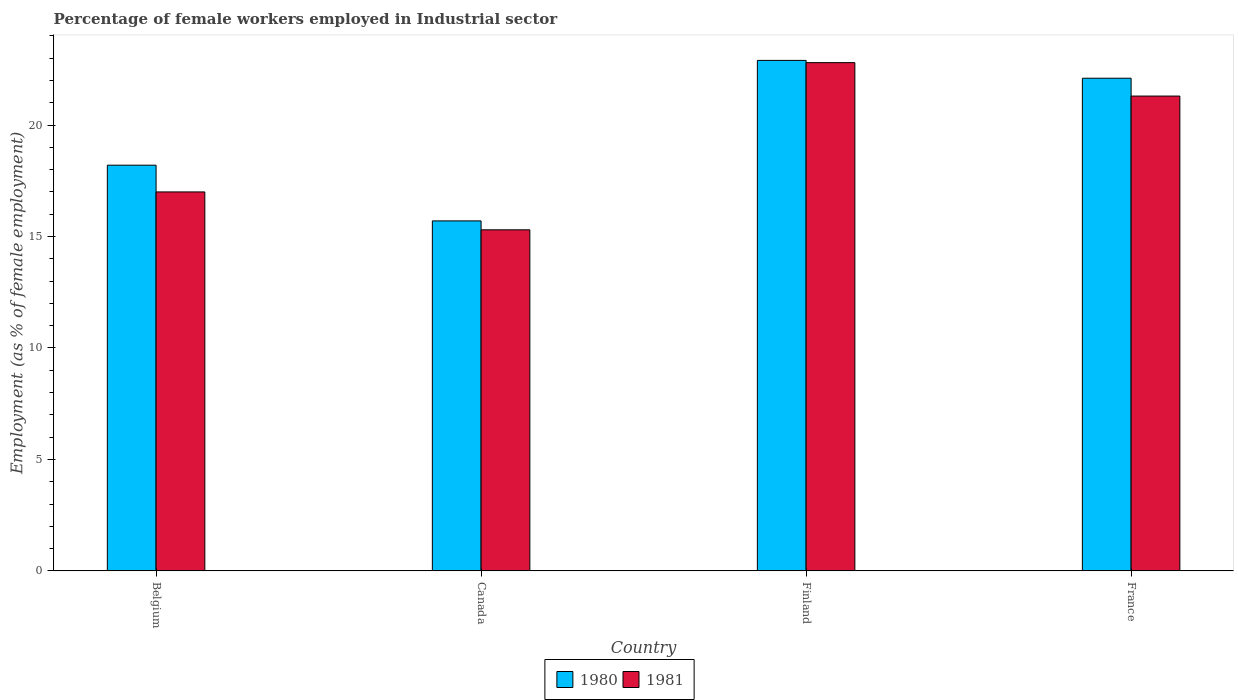Are the number of bars per tick equal to the number of legend labels?
Offer a terse response. Yes. What is the percentage of females employed in Industrial sector in 1981 in Finland?
Your answer should be compact. 22.8. Across all countries, what is the maximum percentage of females employed in Industrial sector in 1981?
Give a very brief answer. 22.8. Across all countries, what is the minimum percentage of females employed in Industrial sector in 1980?
Offer a terse response. 15.7. In which country was the percentage of females employed in Industrial sector in 1980 maximum?
Keep it short and to the point. Finland. In which country was the percentage of females employed in Industrial sector in 1980 minimum?
Give a very brief answer. Canada. What is the total percentage of females employed in Industrial sector in 1980 in the graph?
Provide a succinct answer. 78.9. What is the difference between the percentage of females employed in Industrial sector in 1980 in Belgium and that in Finland?
Offer a terse response. -4.7. What is the difference between the percentage of females employed in Industrial sector in 1981 in Finland and the percentage of females employed in Industrial sector in 1980 in Belgium?
Your response must be concise. 4.6. What is the average percentage of females employed in Industrial sector in 1981 per country?
Provide a short and direct response. 19.1. What is the difference between the percentage of females employed in Industrial sector of/in 1980 and percentage of females employed in Industrial sector of/in 1981 in France?
Your response must be concise. 0.8. In how many countries, is the percentage of females employed in Industrial sector in 1980 greater than 2 %?
Your answer should be very brief. 4. What is the ratio of the percentage of females employed in Industrial sector in 1980 in Belgium to that in France?
Provide a short and direct response. 0.82. Is the percentage of females employed in Industrial sector in 1981 in Belgium less than that in Finland?
Your response must be concise. Yes. Is the difference between the percentage of females employed in Industrial sector in 1980 in Canada and Finland greater than the difference between the percentage of females employed in Industrial sector in 1981 in Canada and Finland?
Your answer should be very brief. Yes. What is the difference between the highest and the second highest percentage of females employed in Industrial sector in 1981?
Keep it short and to the point. -4.3. What is the difference between the highest and the lowest percentage of females employed in Industrial sector in 1981?
Make the answer very short. 7.5. In how many countries, is the percentage of females employed in Industrial sector in 1980 greater than the average percentage of females employed in Industrial sector in 1980 taken over all countries?
Your answer should be very brief. 2. What does the 1st bar from the left in Canada represents?
Give a very brief answer. 1980. How many bars are there?
Your answer should be very brief. 8. Are all the bars in the graph horizontal?
Provide a short and direct response. No. What is the difference between two consecutive major ticks on the Y-axis?
Offer a terse response. 5. Where does the legend appear in the graph?
Provide a short and direct response. Bottom center. How are the legend labels stacked?
Your answer should be very brief. Horizontal. What is the title of the graph?
Ensure brevity in your answer.  Percentage of female workers employed in Industrial sector. Does "2006" appear as one of the legend labels in the graph?
Ensure brevity in your answer.  No. What is the label or title of the Y-axis?
Provide a short and direct response. Employment (as % of female employment). What is the Employment (as % of female employment) of 1980 in Belgium?
Your response must be concise. 18.2. What is the Employment (as % of female employment) in 1981 in Belgium?
Provide a short and direct response. 17. What is the Employment (as % of female employment) in 1980 in Canada?
Provide a succinct answer. 15.7. What is the Employment (as % of female employment) in 1981 in Canada?
Give a very brief answer. 15.3. What is the Employment (as % of female employment) of 1980 in Finland?
Keep it short and to the point. 22.9. What is the Employment (as % of female employment) in 1981 in Finland?
Provide a short and direct response. 22.8. What is the Employment (as % of female employment) in 1980 in France?
Keep it short and to the point. 22.1. What is the Employment (as % of female employment) of 1981 in France?
Make the answer very short. 21.3. Across all countries, what is the maximum Employment (as % of female employment) of 1980?
Offer a very short reply. 22.9. Across all countries, what is the maximum Employment (as % of female employment) in 1981?
Give a very brief answer. 22.8. Across all countries, what is the minimum Employment (as % of female employment) in 1980?
Your answer should be very brief. 15.7. Across all countries, what is the minimum Employment (as % of female employment) in 1981?
Your response must be concise. 15.3. What is the total Employment (as % of female employment) of 1980 in the graph?
Offer a terse response. 78.9. What is the total Employment (as % of female employment) of 1981 in the graph?
Keep it short and to the point. 76.4. What is the difference between the Employment (as % of female employment) of 1980 in Belgium and that in Canada?
Keep it short and to the point. 2.5. What is the difference between the Employment (as % of female employment) of 1981 in Belgium and that in Canada?
Make the answer very short. 1.7. What is the difference between the Employment (as % of female employment) of 1980 in Belgium and that in Finland?
Your response must be concise. -4.7. What is the difference between the Employment (as % of female employment) in 1981 in Belgium and that in Finland?
Offer a very short reply. -5.8. What is the difference between the Employment (as % of female employment) of 1980 in Canada and that in France?
Ensure brevity in your answer.  -6.4. What is the difference between the Employment (as % of female employment) in 1980 in Finland and that in France?
Provide a succinct answer. 0.8. What is the difference between the Employment (as % of female employment) in 1981 in Finland and that in France?
Offer a terse response. 1.5. What is the difference between the Employment (as % of female employment) of 1980 in Belgium and the Employment (as % of female employment) of 1981 in Canada?
Keep it short and to the point. 2.9. What is the difference between the Employment (as % of female employment) in 1980 in Belgium and the Employment (as % of female employment) in 1981 in Finland?
Provide a succinct answer. -4.6. What is the difference between the Employment (as % of female employment) of 1980 in Belgium and the Employment (as % of female employment) of 1981 in France?
Offer a terse response. -3.1. What is the difference between the Employment (as % of female employment) of 1980 in Canada and the Employment (as % of female employment) of 1981 in France?
Give a very brief answer. -5.6. What is the average Employment (as % of female employment) of 1980 per country?
Your answer should be compact. 19.73. What is the difference between the Employment (as % of female employment) of 1980 and Employment (as % of female employment) of 1981 in Canada?
Give a very brief answer. 0.4. What is the ratio of the Employment (as % of female employment) in 1980 in Belgium to that in Canada?
Your answer should be compact. 1.16. What is the ratio of the Employment (as % of female employment) in 1981 in Belgium to that in Canada?
Provide a short and direct response. 1.11. What is the ratio of the Employment (as % of female employment) of 1980 in Belgium to that in Finland?
Your answer should be very brief. 0.79. What is the ratio of the Employment (as % of female employment) in 1981 in Belgium to that in Finland?
Your response must be concise. 0.75. What is the ratio of the Employment (as % of female employment) of 1980 in Belgium to that in France?
Offer a very short reply. 0.82. What is the ratio of the Employment (as % of female employment) of 1981 in Belgium to that in France?
Keep it short and to the point. 0.8. What is the ratio of the Employment (as % of female employment) of 1980 in Canada to that in Finland?
Keep it short and to the point. 0.69. What is the ratio of the Employment (as % of female employment) of 1981 in Canada to that in Finland?
Make the answer very short. 0.67. What is the ratio of the Employment (as % of female employment) in 1980 in Canada to that in France?
Keep it short and to the point. 0.71. What is the ratio of the Employment (as % of female employment) in 1981 in Canada to that in France?
Make the answer very short. 0.72. What is the ratio of the Employment (as % of female employment) in 1980 in Finland to that in France?
Provide a succinct answer. 1.04. What is the ratio of the Employment (as % of female employment) in 1981 in Finland to that in France?
Provide a short and direct response. 1.07. What is the difference between the highest and the lowest Employment (as % of female employment) in 1980?
Keep it short and to the point. 7.2. 